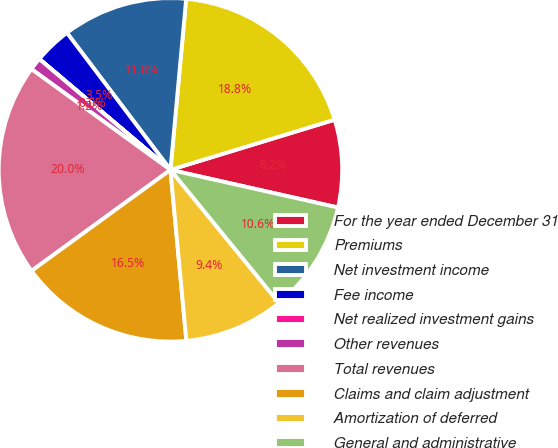Convert chart. <chart><loc_0><loc_0><loc_500><loc_500><pie_chart><fcel>For the year ended December 31<fcel>Premiums<fcel>Net investment income<fcel>Fee income<fcel>Net realized investment gains<fcel>Other revenues<fcel>Total revenues<fcel>Claims and claim adjustment<fcel>Amortization of deferred<fcel>General and administrative<nl><fcel>8.24%<fcel>18.82%<fcel>11.76%<fcel>3.53%<fcel>0.01%<fcel>1.18%<fcel>19.99%<fcel>16.47%<fcel>9.41%<fcel>10.59%<nl></chart> 